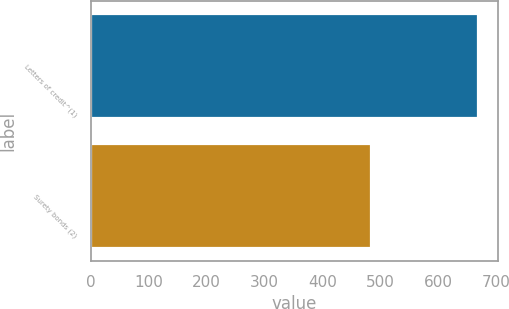<chart> <loc_0><loc_0><loc_500><loc_500><bar_chart><fcel>Letters of credit^(1)<fcel>Surety bonds (2)<nl><fcel>669.1<fcel>484.2<nl></chart> 